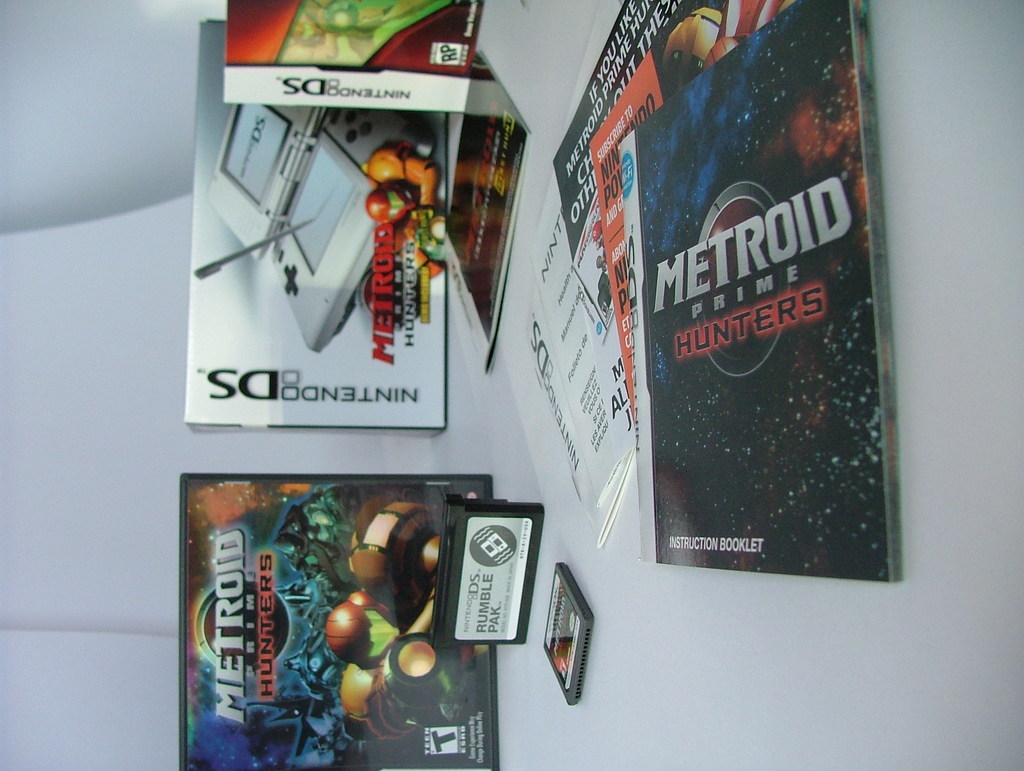<image>
Create a compact narrative representing the image presented. An instruction booklet for Nintendo DS Metroid Prime Hunters sits on a white table 